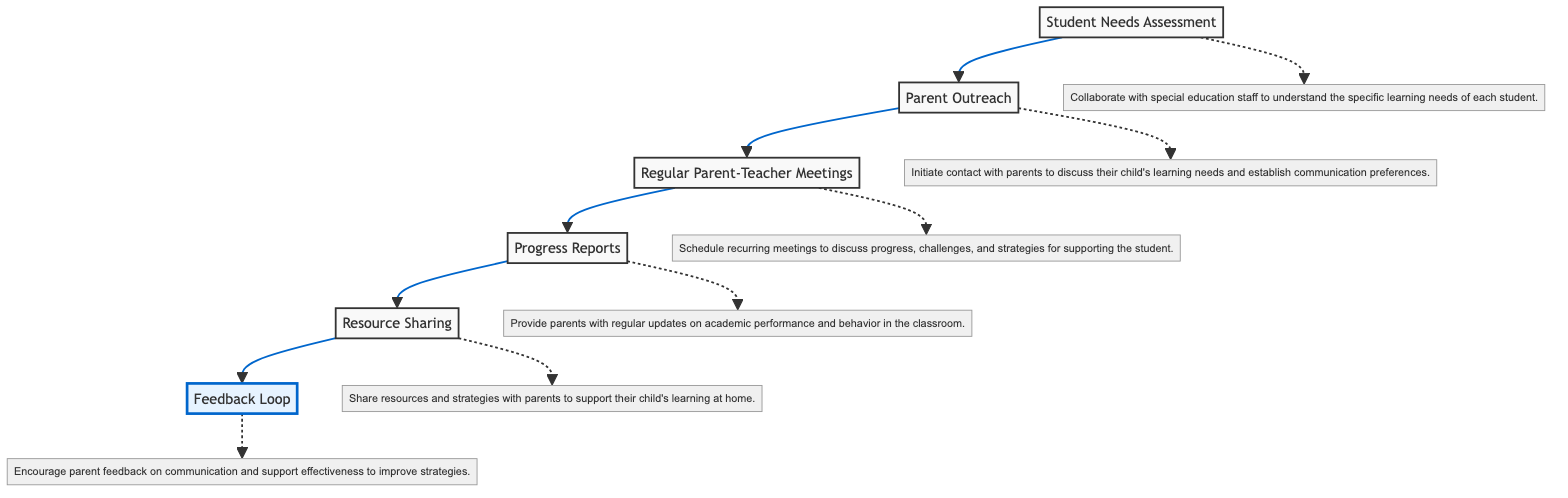What is the first step in the communication process? The first step is represented by the node "Student Needs Assessment," which is the starting point for assessing the specific learning needs of each student.
Answer: Student Needs Assessment How many nodes are in the diagram? The diagram contains six nodes: Student Needs Assessment, Parent Outreach, Regular Parent-Teacher Meetings, Progress Reports, Resource Sharing, and Feedback Loop.
Answer: 6 Which step follows "Parent Outreach"? After "Parent Outreach," the next step is "Regular Parent-Teacher Meetings," indicating the sequence of actions in the process.
Answer: Regular Parent-Teacher Meetings What is the last step in the communication process? The last step in the communication flow is "Feedback Loop," which emphasizes the importance of receiving feedback from parents.
Answer: Feedback Loop What is described in the "Progress Reports" node? The "Progress Reports" node provides regular updates on the child's academic performance and behavior in the classroom, helping parents stay informed.
Answer: Provide parents with regular updates on academic performance and behavior in the classroom How does "Resource Sharing" relate to "Progress Reports"? "Resource Sharing" follows "Progress Reports," indicating that after informing parents about progress, sharing resources for home support is the next action in the process.
Answer: It follows the "Progress Reports" step Why is the "Feedback Loop" step important? The "Feedback Loop" step is crucial as it allows for parent input on the communication process, which can lead to improvements in the strategies employed by teachers.
Answer: It encourages parent feedback on communication and support effectiveness to improve strategies What is the purpose of "Parent Outreach"? The purpose of "Parent Outreach" is to initiate communication with parents regarding their child's learning needs and preferences, establishing a foundation for ongoing dialogue.
Answer: Initiate contact with parents to discuss their child's learning needs and establish communication preferences 